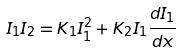<formula> <loc_0><loc_0><loc_500><loc_500>I _ { 1 } I _ { 2 } = K _ { 1 } I ^ { 2 } _ { 1 } + K _ { 2 } I _ { 1 } \frac { d I _ { 1 } } { d x }</formula> 